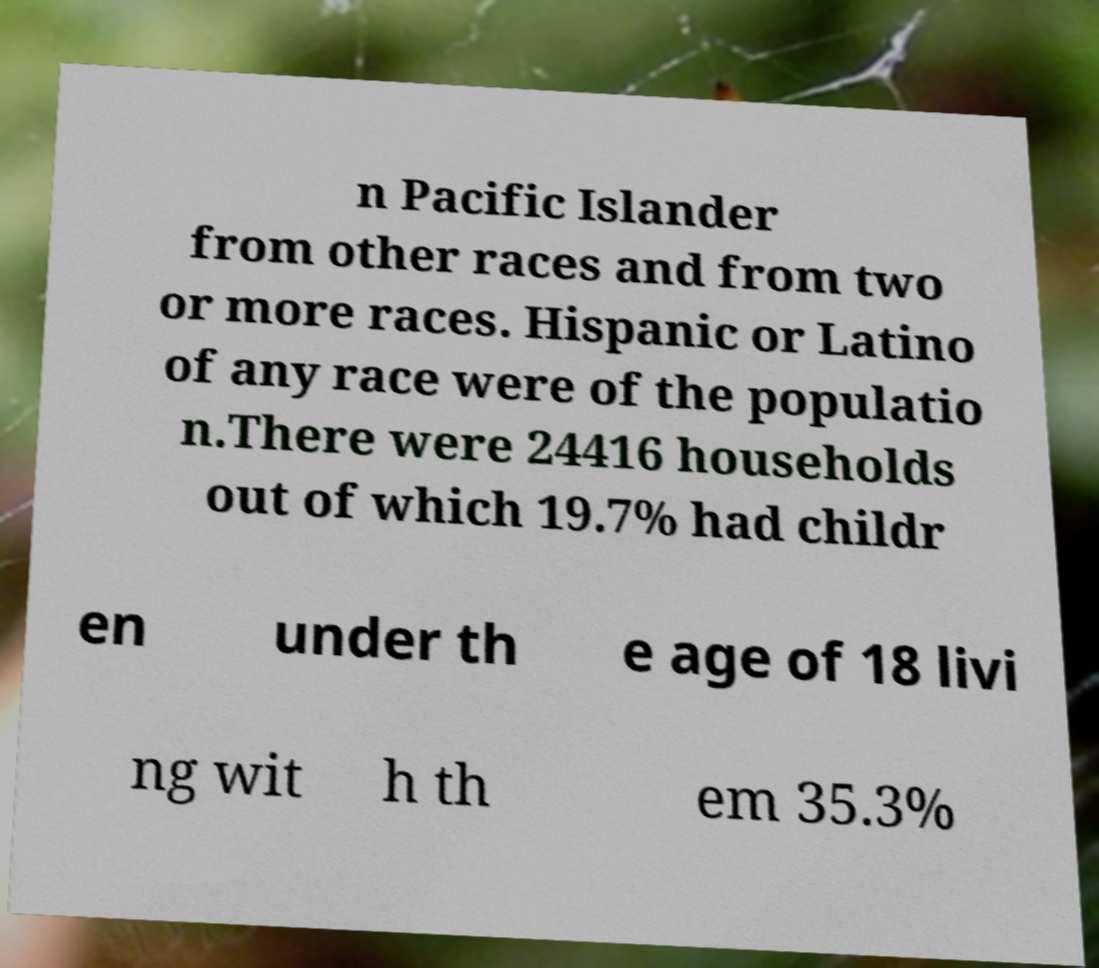Could you assist in decoding the text presented in this image and type it out clearly? n Pacific Islander from other races and from two or more races. Hispanic or Latino of any race were of the populatio n.There were 24416 households out of which 19.7% had childr en under th e age of 18 livi ng wit h th em 35.3% 